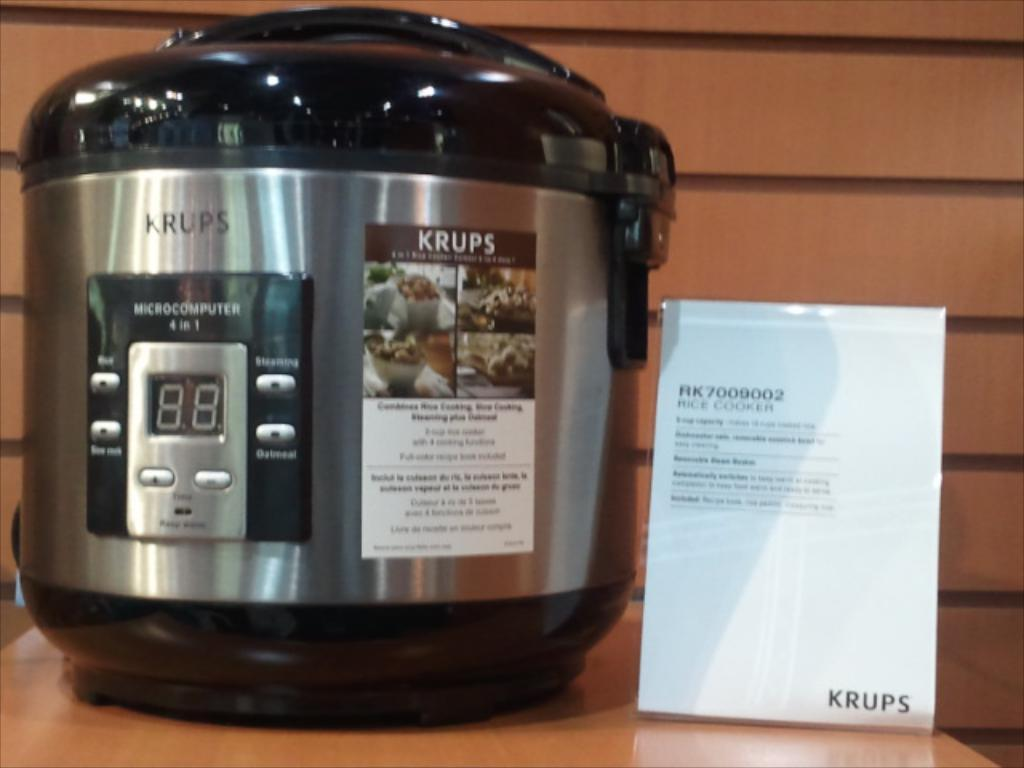Provide a one-sentence caption for the provided image. A pressure cooker that is for sale is on a shelf. 